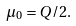Convert formula to latex. <formula><loc_0><loc_0><loc_500><loc_500>\mu _ { 0 } = Q / 2 .</formula> 